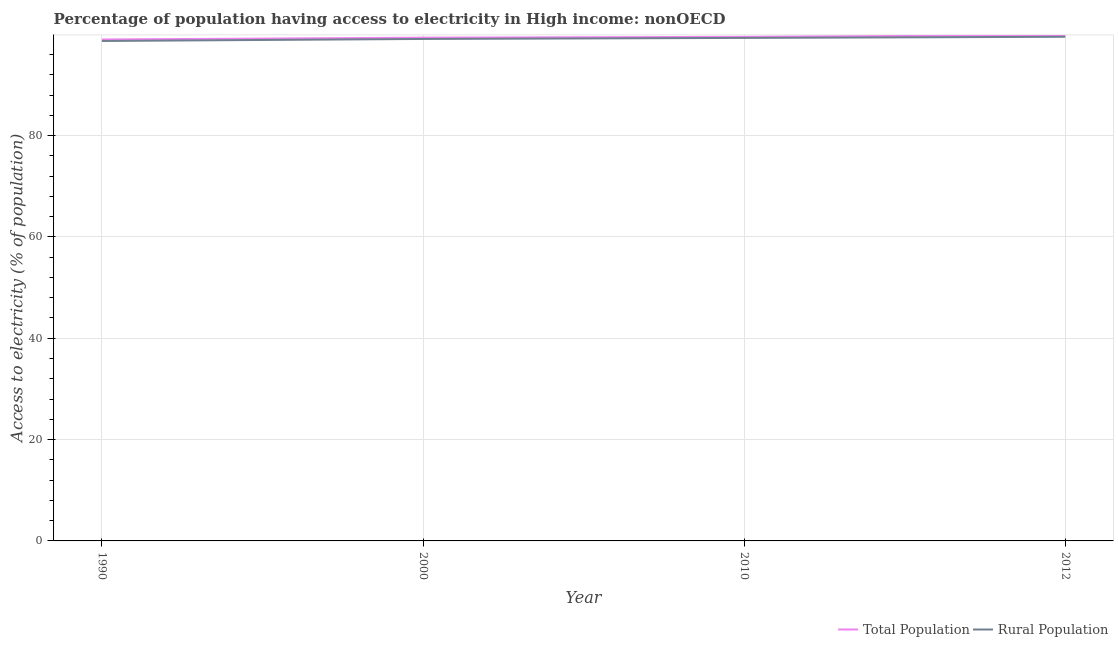How many different coloured lines are there?
Keep it short and to the point. 2. Does the line corresponding to percentage of rural population having access to electricity intersect with the line corresponding to percentage of population having access to electricity?
Keep it short and to the point. No. Is the number of lines equal to the number of legend labels?
Provide a succinct answer. Yes. What is the percentage of population having access to electricity in 2000?
Keep it short and to the point. 99.33. Across all years, what is the maximum percentage of rural population having access to electricity?
Your answer should be very brief. 99.5. Across all years, what is the minimum percentage of rural population having access to electricity?
Offer a terse response. 98.67. In which year was the percentage of rural population having access to electricity minimum?
Provide a short and direct response. 1990. What is the total percentage of population having access to electricity in the graph?
Keep it short and to the point. 397.62. What is the difference between the percentage of population having access to electricity in 2010 and that in 2012?
Provide a succinct answer. -0.33. What is the difference between the percentage of rural population having access to electricity in 2010 and the percentage of population having access to electricity in 2000?
Offer a very short reply. -0.05. What is the average percentage of population having access to electricity per year?
Offer a very short reply. 99.4. In the year 2000, what is the difference between the percentage of population having access to electricity and percentage of rural population having access to electricity?
Offer a very short reply. 0.25. In how many years, is the percentage of rural population having access to electricity greater than 72 %?
Keep it short and to the point. 4. What is the ratio of the percentage of population having access to electricity in 1990 to that in 2012?
Offer a very short reply. 0.99. Is the percentage of rural population having access to electricity in 1990 less than that in 2012?
Your answer should be compact. Yes. Is the difference between the percentage of population having access to electricity in 1990 and 2010 greater than the difference between the percentage of rural population having access to electricity in 1990 and 2010?
Offer a very short reply. Yes. What is the difference between the highest and the second highest percentage of rural population having access to electricity?
Your response must be concise. 0.22. What is the difference between the highest and the lowest percentage of rural population having access to electricity?
Make the answer very short. 0.83. Is the sum of the percentage of population having access to electricity in 2000 and 2010 greater than the maximum percentage of rural population having access to electricity across all years?
Offer a terse response. Yes. How many lines are there?
Offer a terse response. 2. Are the values on the major ticks of Y-axis written in scientific E-notation?
Provide a short and direct response. No. Does the graph contain any zero values?
Provide a succinct answer. No. How are the legend labels stacked?
Ensure brevity in your answer.  Horizontal. What is the title of the graph?
Provide a succinct answer. Percentage of population having access to electricity in High income: nonOECD. What is the label or title of the Y-axis?
Make the answer very short. Access to electricity (% of population). What is the Access to electricity (% of population) in Total Population in 1990?
Provide a short and direct response. 98.97. What is the Access to electricity (% of population) in Rural Population in 1990?
Your answer should be compact. 98.67. What is the Access to electricity (% of population) of Total Population in 2000?
Provide a succinct answer. 99.33. What is the Access to electricity (% of population) in Rural Population in 2000?
Ensure brevity in your answer.  99.08. What is the Access to electricity (% of population) of Total Population in 2010?
Offer a terse response. 99.49. What is the Access to electricity (% of population) of Rural Population in 2010?
Your answer should be very brief. 99.28. What is the Access to electricity (% of population) in Total Population in 2012?
Offer a terse response. 99.82. What is the Access to electricity (% of population) of Rural Population in 2012?
Your answer should be compact. 99.5. Across all years, what is the maximum Access to electricity (% of population) in Total Population?
Give a very brief answer. 99.82. Across all years, what is the maximum Access to electricity (% of population) in Rural Population?
Provide a short and direct response. 99.5. Across all years, what is the minimum Access to electricity (% of population) of Total Population?
Your answer should be very brief. 98.97. Across all years, what is the minimum Access to electricity (% of population) in Rural Population?
Provide a short and direct response. 98.67. What is the total Access to electricity (% of population) in Total Population in the graph?
Make the answer very short. 397.62. What is the total Access to electricity (% of population) in Rural Population in the graph?
Offer a very short reply. 396.54. What is the difference between the Access to electricity (% of population) in Total Population in 1990 and that in 2000?
Provide a succinct answer. -0.36. What is the difference between the Access to electricity (% of population) in Rural Population in 1990 and that in 2000?
Keep it short and to the point. -0.4. What is the difference between the Access to electricity (% of population) in Total Population in 1990 and that in 2010?
Make the answer very short. -0.52. What is the difference between the Access to electricity (% of population) of Rural Population in 1990 and that in 2010?
Provide a short and direct response. -0.61. What is the difference between the Access to electricity (% of population) of Total Population in 1990 and that in 2012?
Offer a very short reply. -0.85. What is the difference between the Access to electricity (% of population) of Rural Population in 1990 and that in 2012?
Keep it short and to the point. -0.83. What is the difference between the Access to electricity (% of population) of Total Population in 2000 and that in 2010?
Keep it short and to the point. -0.16. What is the difference between the Access to electricity (% of population) in Rural Population in 2000 and that in 2010?
Your response must be concise. -0.21. What is the difference between the Access to electricity (% of population) of Total Population in 2000 and that in 2012?
Keep it short and to the point. -0.49. What is the difference between the Access to electricity (% of population) of Rural Population in 2000 and that in 2012?
Make the answer very short. -0.43. What is the difference between the Access to electricity (% of population) in Total Population in 2010 and that in 2012?
Your response must be concise. -0.33. What is the difference between the Access to electricity (% of population) in Rural Population in 2010 and that in 2012?
Provide a short and direct response. -0.22. What is the difference between the Access to electricity (% of population) of Total Population in 1990 and the Access to electricity (% of population) of Rural Population in 2000?
Keep it short and to the point. -0.1. What is the difference between the Access to electricity (% of population) in Total Population in 1990 and the Access to electricity (% of population) in Rural Population in 2010?
Give a very brief answer. -0.31. What is the difference between the Access to electricity (% of population) in Total Population in 1990 and the Access to electricity (% of population) in Rural Population in 2012?
Provide a succinct answer. -0.53. What is the difference between the Access to electricity (% of population) of Total Population in 2000 and the Access to electricity (% of population) of Rural Population in 2010?
Give a very brief answer. 0.05. What is the difference between the Access to electricity (% of population) in Total Population in 2000 and the Access to electricity (% of population) in Rural Population in 2012?
Make the answer very short. -0.17. What is the difference between the Access to electricity (% of population) of Total Population in 2010 and the Access to electricity (% of population) of Rural Population in 2012?
Your answer should be compact. -0.01. What is the average Access to electricity (% of population) in Total Population per year?
Offer a very short reply. 99.4. What is the average Access to electricity (% of population) in Rural Population per year?
Your answer should be compact. 99.13. In the year 1990, what is the difference between the Access to electricity (% of population) of Total Population and Access to electricity (% of population) of Rural Population?
Keep it short and to the point. 0.3. In the year 2000, what is the difference between the Access to electricity (% of population) in Total Population and Access to electricity (% of population) in Rural Population?
Make the answer very short. 0.25. In the year 2010, what is the difference between the Access to electricity (% of population) of Total Population and Access to electricity (% of population) of Rural Population?
Ensure brevity in your answer.  0.21. In the year 2012, what is the difference between the Access to electricity (% of population) in Total Population and Access to electricity (% of population) in Rural Population?
Make the answer very short. 0.32. What is the ratio of the Access to electricity (% of population) in Rural Population in 1990 to that in 2000?
Your answer should be very brief. 1. What is the ratio of the Access to electricity (% of population) in Total Population in 1990 to that in 2010?
Keep it short and to the point. 0.99. What is the ratio of the Access to electricity (% of population) in Rural Population in 1990 to that in 2012?
Your answer should be compact. 0.99. What is the ratio of the Access to electricity (% of population) in Total Population in 2000 to that in 2012?
Your response must be concise. 1. What is the ratio of the Access to electricity (% of population) in Total Population in 2010 to that in 2012?
Offer a very short reply. 1. What is the difference between the highest and the second highest Access to electricity (% of population) of Total Population?
Ensure brevity in your answer.  0.33. What is the difference between the highest and the second highest Access to electricity (% of population) of Rural Population?
Your answer should be compact. 0.22. What is the difference between the highest and the lowest Access to electricity (% of population) of Total Population?
Provide a short and direct response. 0.85. What is the difference between the highest and the lowest Access to electricity (% of population) in Rural Population?
Make the answer very short. 0.83. 